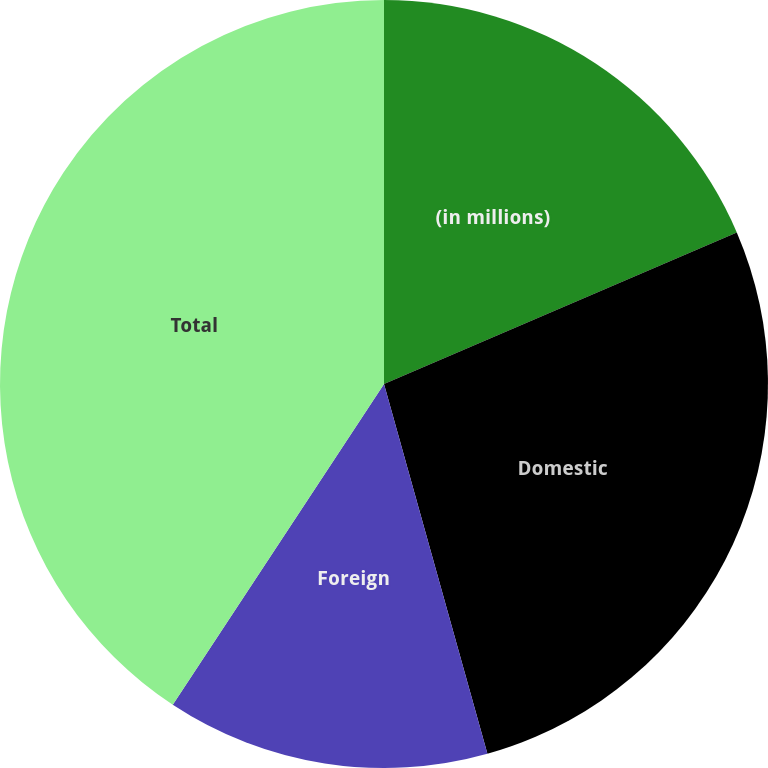<chart> <loc_0><loc_0><loc_500><loc_500><pie_chart><fcel>(in millions)<fcel>Domestic<fcel>Foreign<fcel>Total<nl><fcel>18.54%<fcel>27.12%<fcel>13.61%<fcel>40.73%<nl></chart> 